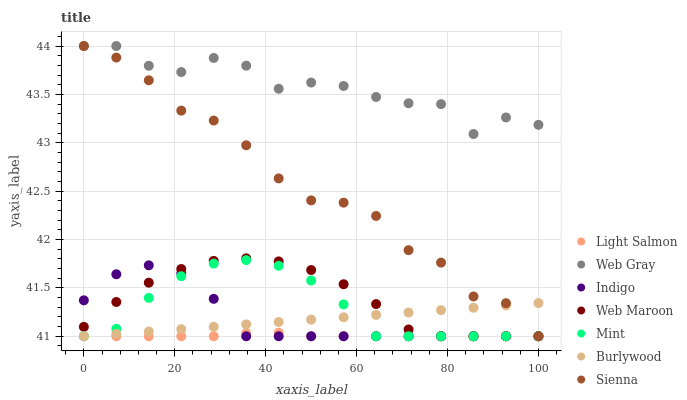Does Light Salmon have the minimum area under the curve?
Answer yes or no. Yes. Does Web Gray have the maximum area under the curve?
Answer yes or no. Yes. Does Indigo have the minimum area under the curve?
Answer yes or no. No. Does Indigo have the maximum area under the curve?
Answer yes or no. No. Is Burlywood the smoothest?
Answer yes or no. Yes. Is Web Gray the roughest?
Answer yes or no. Yes. Is Indigo the smoothest?
Answer yes or no. No. Is Indigo the roughest?
Answer yes or no. No. Does Light Salmon have the lowest value?
Answer yes or no. Yes. Does Web Gray have the lowest value?
Answer yes or no. No. Does Sienna have the highest value?
Answer yes or no. Yes. Does Indigo have the highest value?
Answer yes or no. No. Is Light Salmon less than Web Gray?
Answer yes or no. Yes. Is Sienna greater than Mint?
Answer yes or no. Yes. Does Indigo intersect Burlywood?
Answer yes or no. Yes. Is Indigo less than Burlywood?
Answer yes or no. No. Is Indigo greater than Burlywood?
Answer yes or no. No. Does Light Salmon intersect Web Gray?
Answer yes or no. No. 